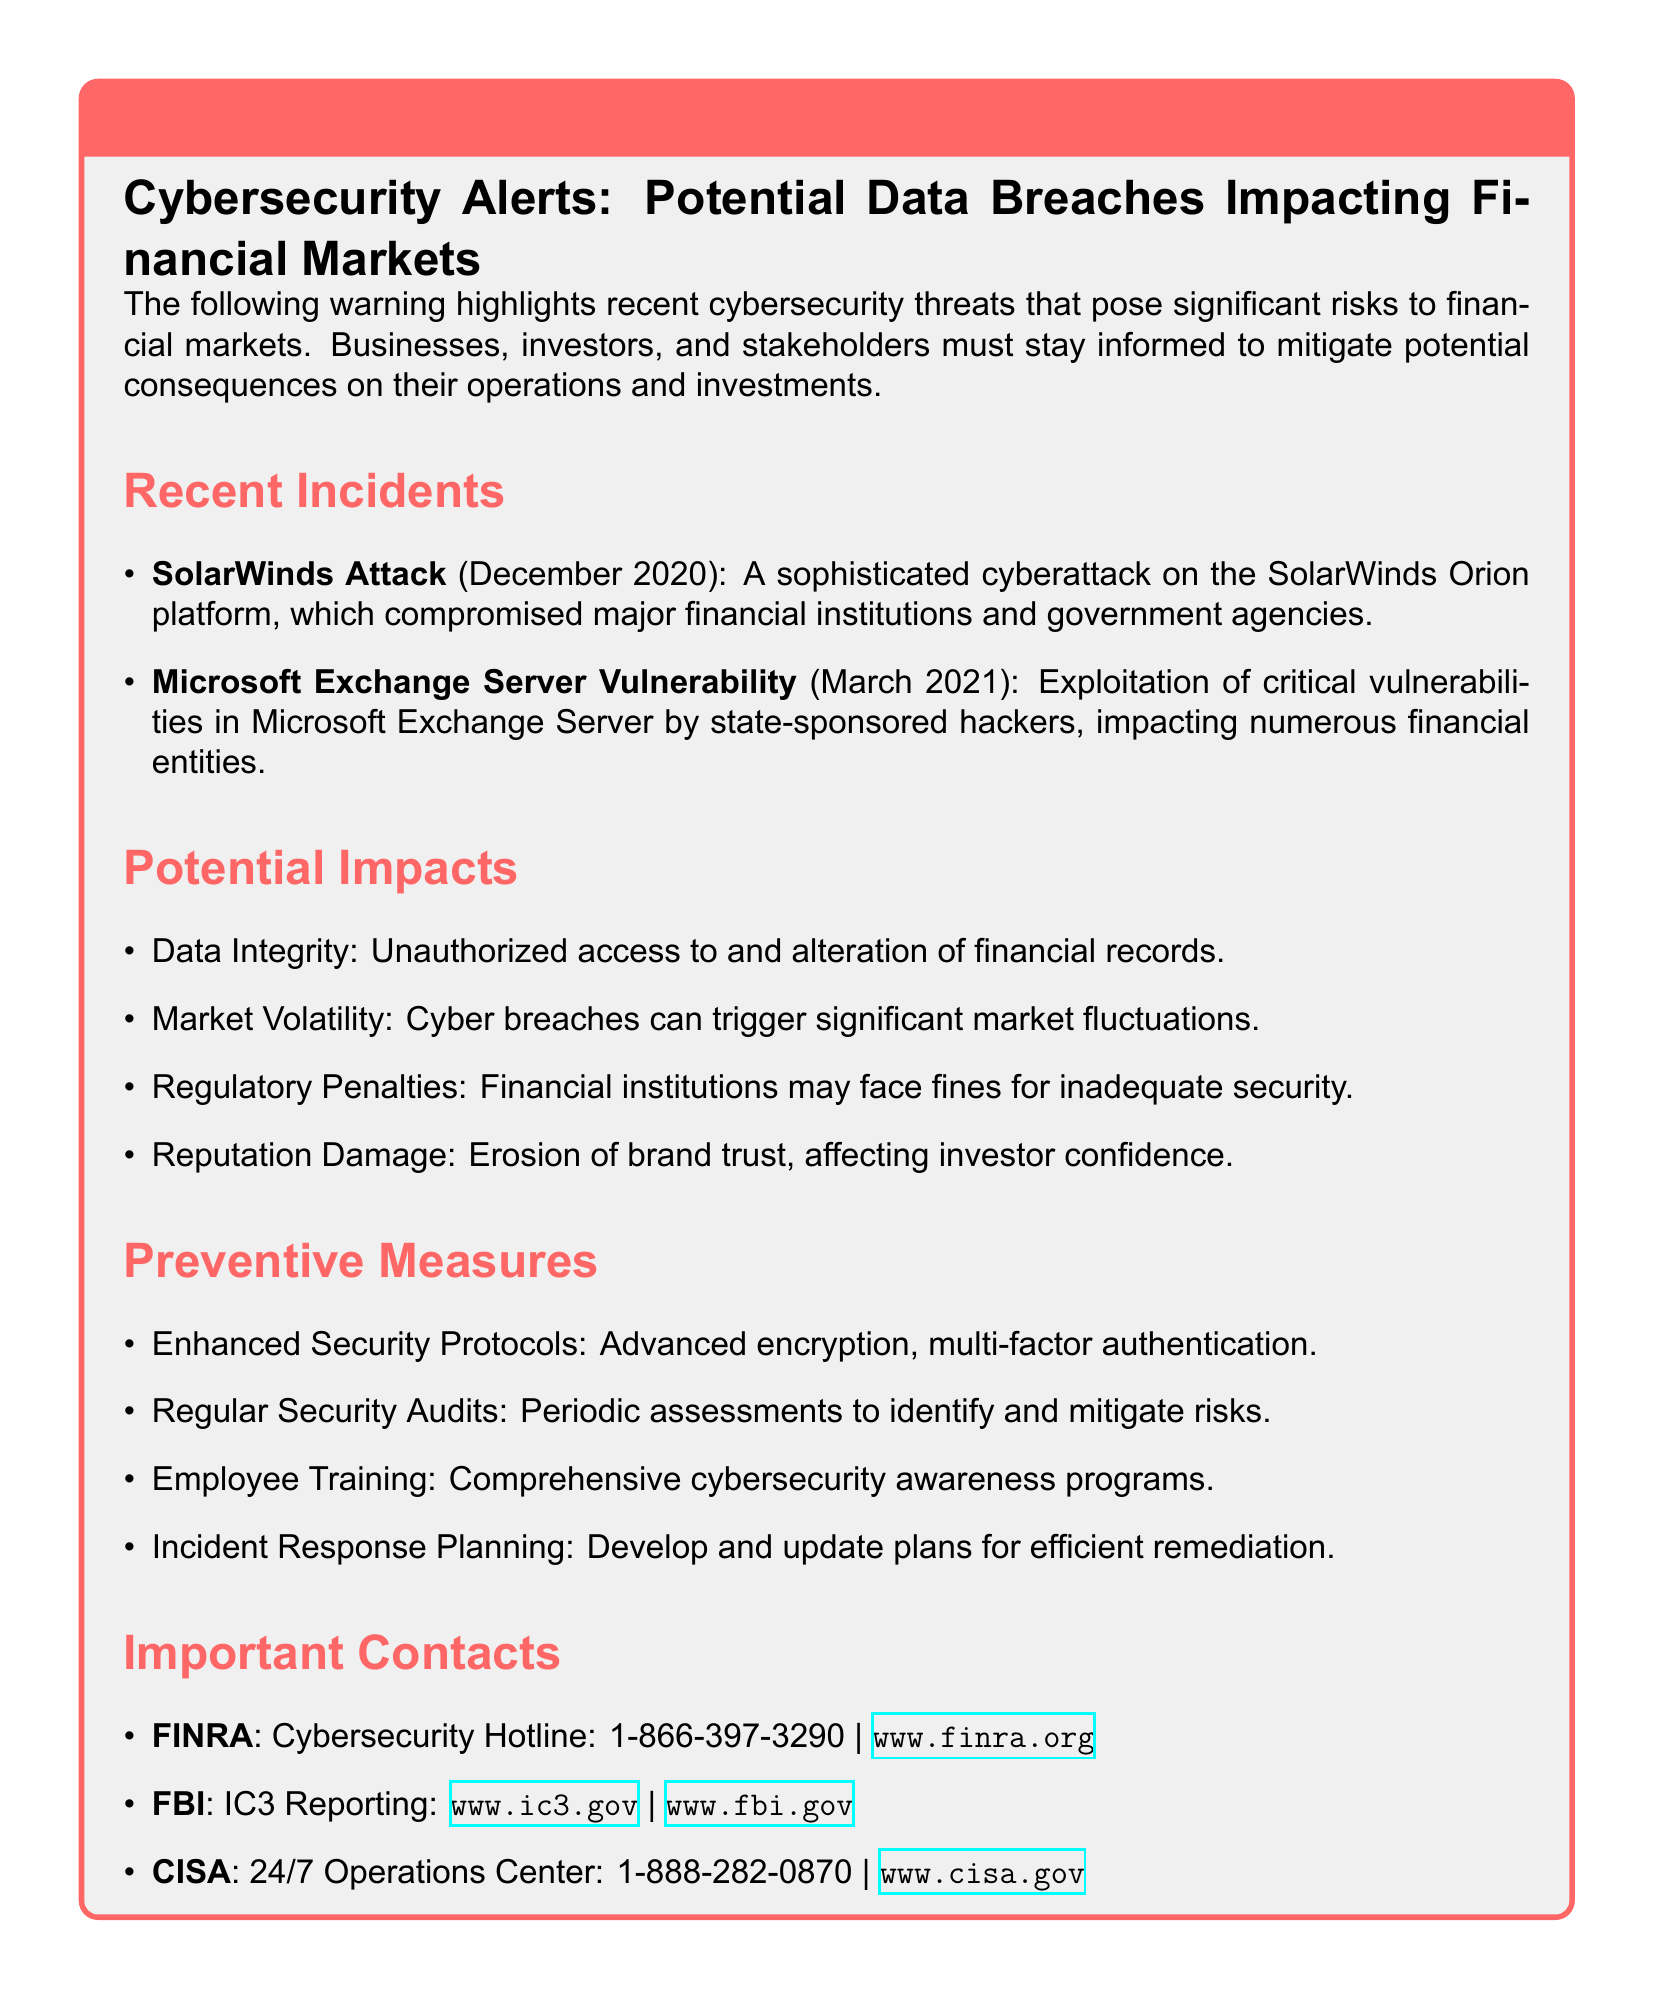What was the date of the SolarWinds attack? The document states that the SolarWinds attack occurred in December 2020.
Answer: December 2020 What is one of the potential impacts of a cyber breach? The document lists several potential impacts, one of which is data integrity compromise.
Answer: Data Integrity What type of vulnerabilities were exploited in the Microsoft Exchange Server incident? The document mentions that critical vulnerabilities were exploited in Microsoft Exchange Server.
Answer: Critical vulnerabilities What is one preventive measure mentioned in the document? The document lists enhanced security protocols as one of the preventive measures.
Answer: Enhanced Security Protocols What organization offers a cybersecurity hotline? The document specifies that FINRA provides a cybersecurity hotline.
Answer: FINRA Which entity is responsible for reporting cyber crimes? The document indicates that the FBI is responsible for IC3 reporting of cyber crimes.
Answer: FBI What can cyber breaches trigger in the financial market? According to the document, cyber breaches can trigger significant market fluctuations.
Answer: Market Volatility How many contacts are listed under Important Contacts? The document includes three important contacts for reporting cybersecurity issues.
Answer: Three 